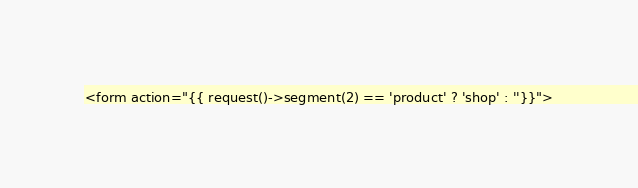Convert code to text. <code><loc_0><loc_0><loc_500><loc_500><_PHP_><form action="{{ request()->segment(2) == 'product' ? 'shop' : ''}}"></code> 